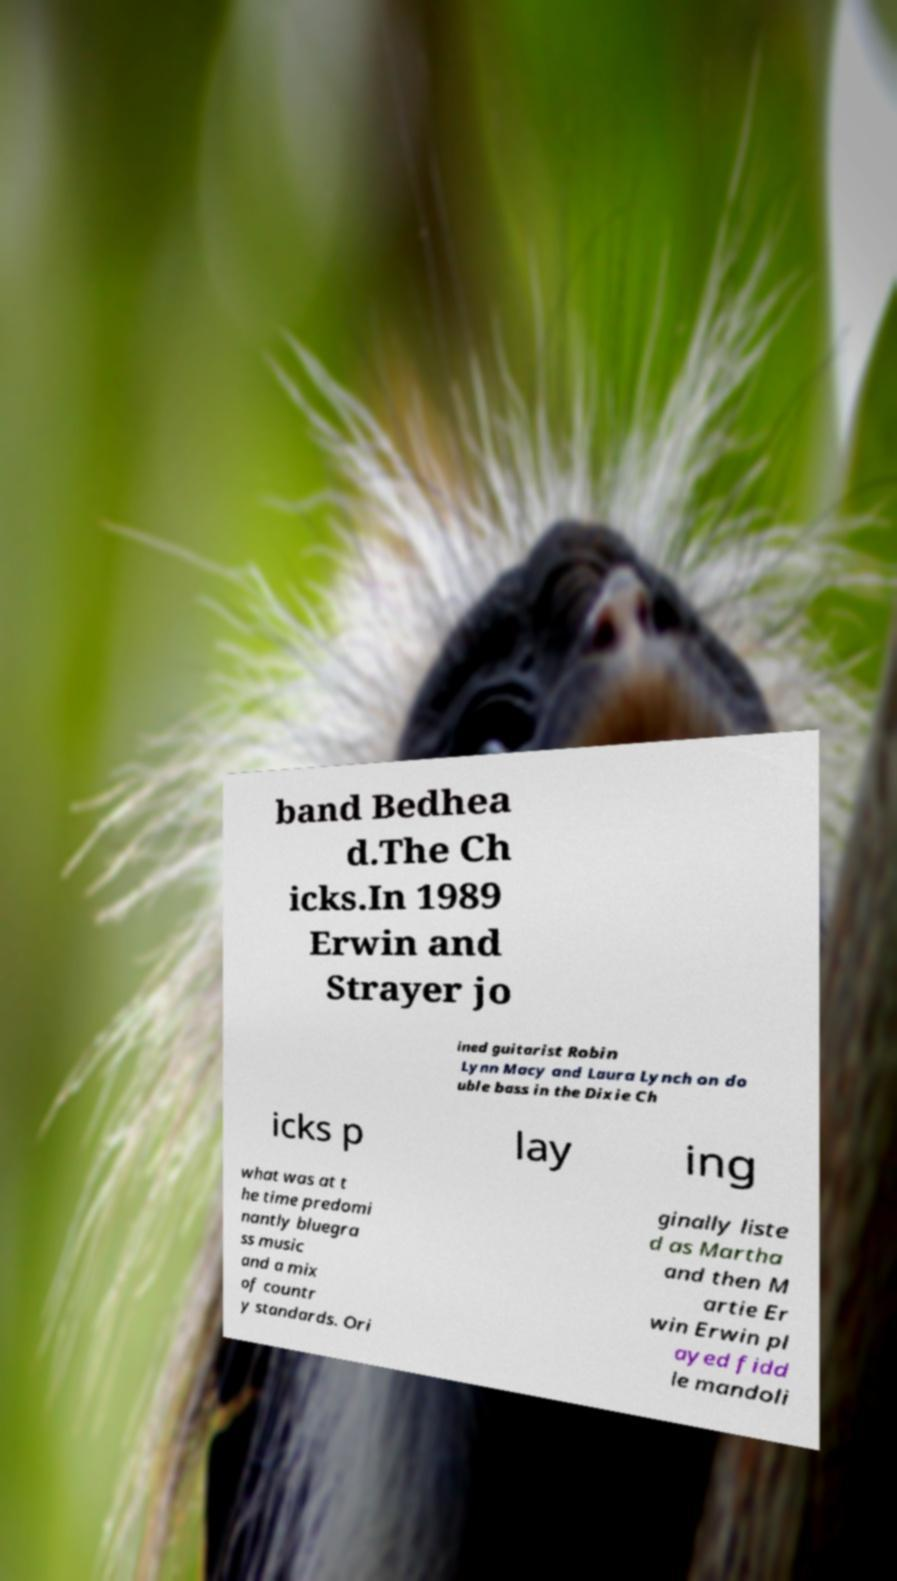Could you assist in decoding the text presented in this image and type it out clearly? band Bedhea d.The Ch icks.In 1989 Erwin and Strayer jo ined guitarist Robin Lynn Macy and Laura Lynch on do uble bass in the Dixie Ch icks p lay ing what was at t he time predomi nantly bluegra ss music and a mix of countr y standards. Ori ginally liste d as Martha and then M artie Er win Erwin pl ayed fidd le mandoli 